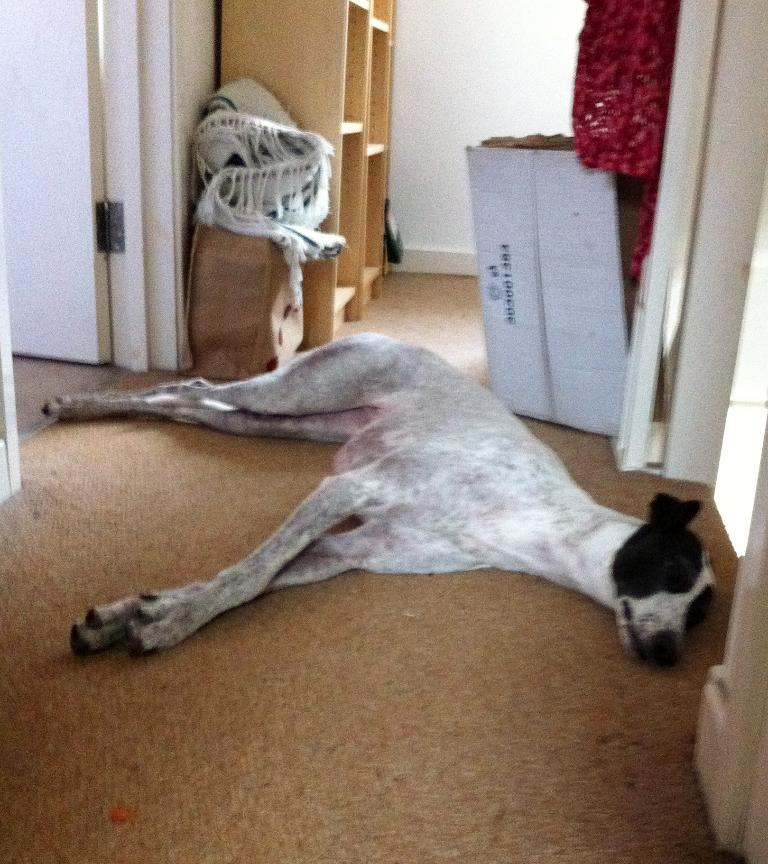What is the animal lying on the floor in the image? There is a dog lying on the floor in the image. What type of furniture can be seen in the image? There are cupboards in the image. What architectural elements are present in the image? There are doors in the image. What type of textile is present in the image? There are blankets in the image. What type of packaging is present in the image? There are cardboard cartons in the image. What type of holiday is being celebrated in the image? There is no indication of a holiday being celebrated in the image. How many quarters are visible in the image? There are no quarters present in the image. 